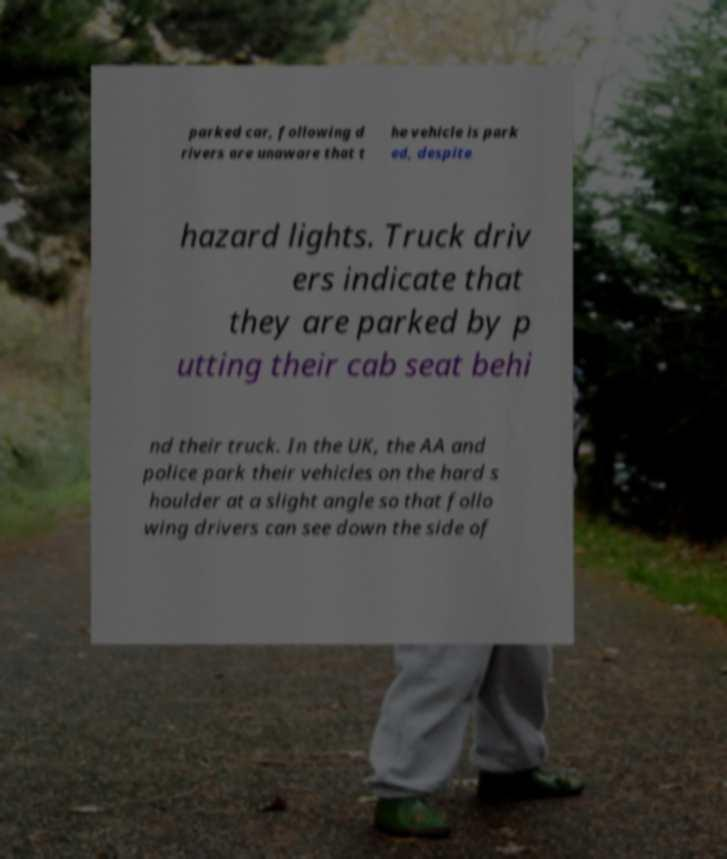Please read and relay the text visible in this image. What does it say? parked car, following d rivers are unaware that t he vehicle is park ed, despite hazard lights. Truck driv ers indicate that they are parked by p utting their cab seat behi nd their truck. In the UK, the AA and police park their vehicles on the hard s houlder at a slight angle so that follo wing drivers can see down the side of 